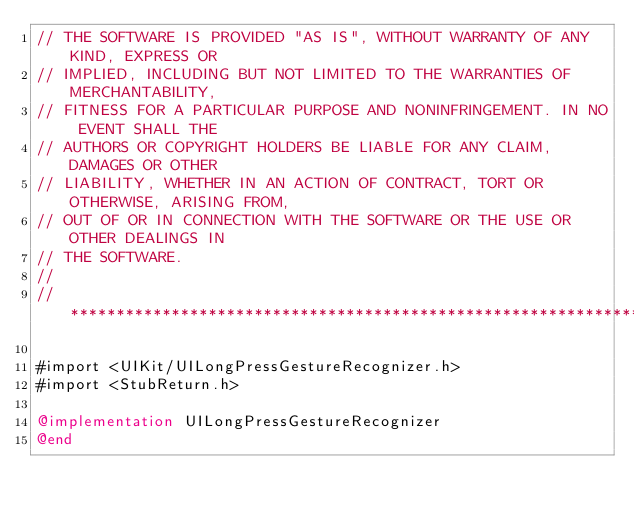Convert code to text. <code><loc_0><loc_0><loc_500><loc_500><_ObjectiveC_>// THE SOFTWARE IS PROVIDED "AS IS", WITHOUT WARRANTY OF ANY KIND, EXPRESS OR
// IMPLIED, INCLUDING BUT NOT LIMITED TO THE WARRANTIES OF MERCHANTABILITY,
// FITNESS FOR A PARTICULAR PURPOSE AND NONINFRINGEMENT. IN NO EVENT SHALL THE
// AUTHORS OR COPYRIGHT HOLDERS BE LIABLE FOR ANY CLAIM, DAMAGES OR OTHER
// LIABILITY, WHETHER IN AN ACTION OF CONTRACT, TORT OR OTHERWISE, ARISING FROM,
// OUT OF OR IN CONNECTION WITH THE SOFTWARE OR THE USE OR OTHER DEALINGS IN
// THE SOFTWARE.
//
//******************************************************************************

#import <UIKit/UILongPressGestureRecognizer.h>
#import <StubReturn.h>

@implementation UILongPressGestureRecognizer
@end
</code> 